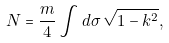Convert formula to latex. <formula><loc_0><loc_0><loc_500><loc_500>N = \frac { m } { 4 } \int d \sigma \, \sqrt { 1 - k ^ { 2 } } ,</formula> 